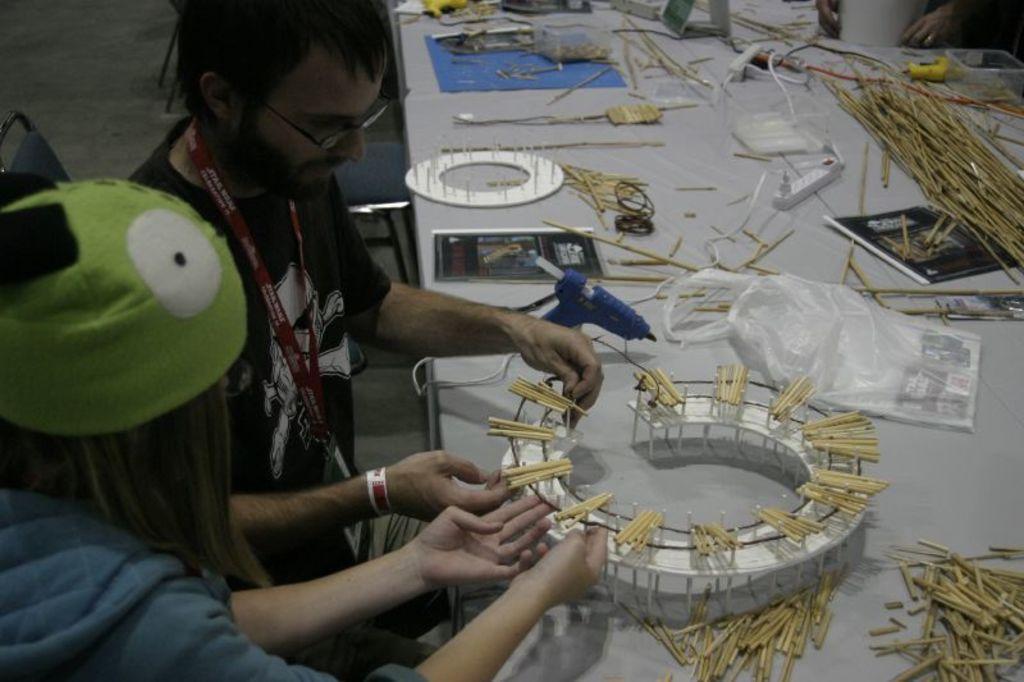Could you give a brief overview of what you see in this image? In this image on the left side I can see two people. On the right side, I can see some objects on the table. 